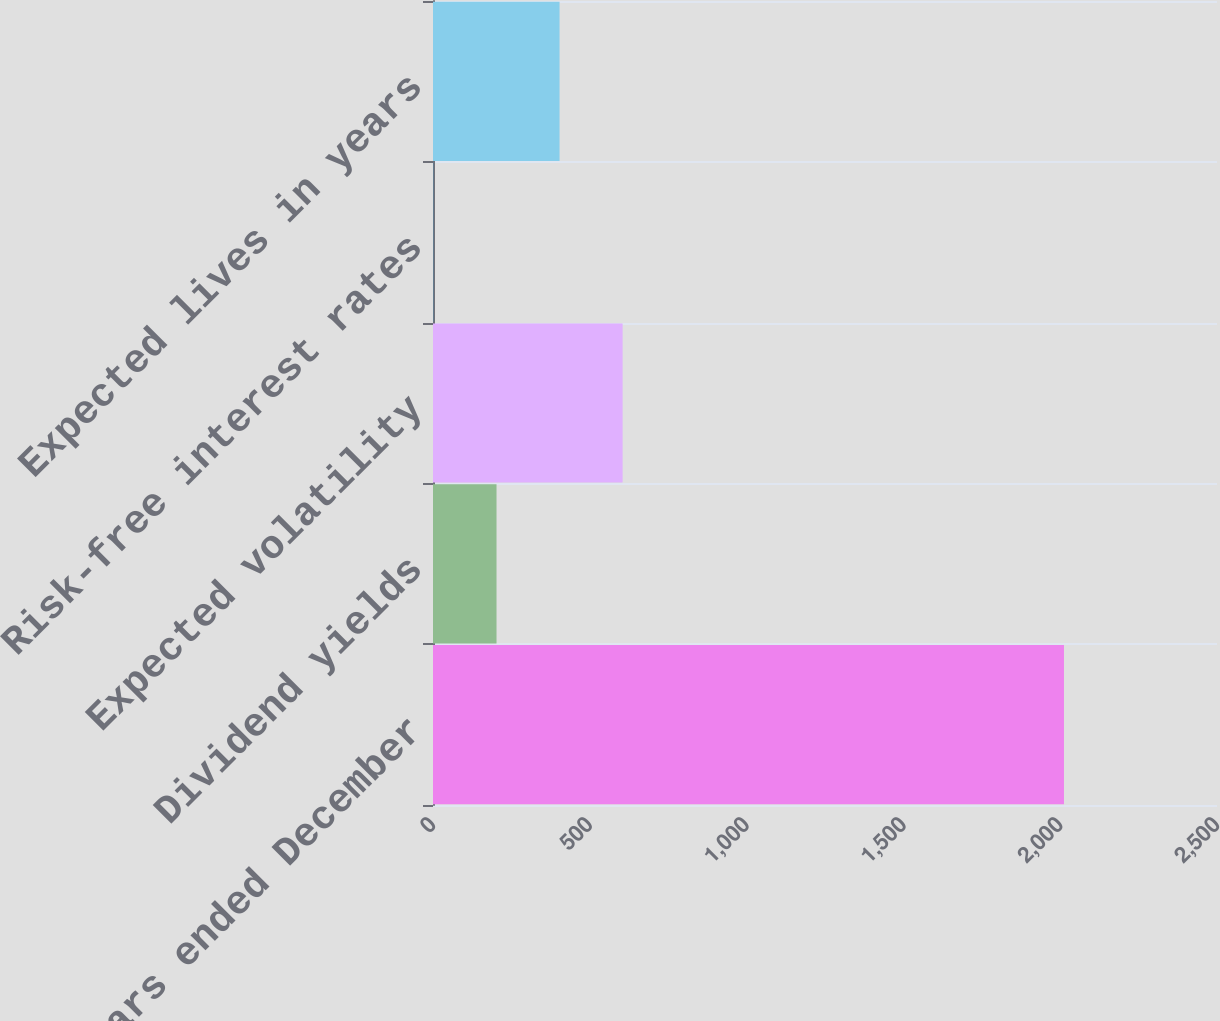<chart> <loc_0><loc_0><loc_500><loc_500><bar_chart><fcel>For the years ended December<fcel>Dividend yields<fcel>Expected volatility<fcel>Risk-free interest rates<fcel>Expected lives in years<nl><fcel>2012<fcel>202.55<fcel>604.65<fcel>1.5<fcel>403.6<nl></chart> 